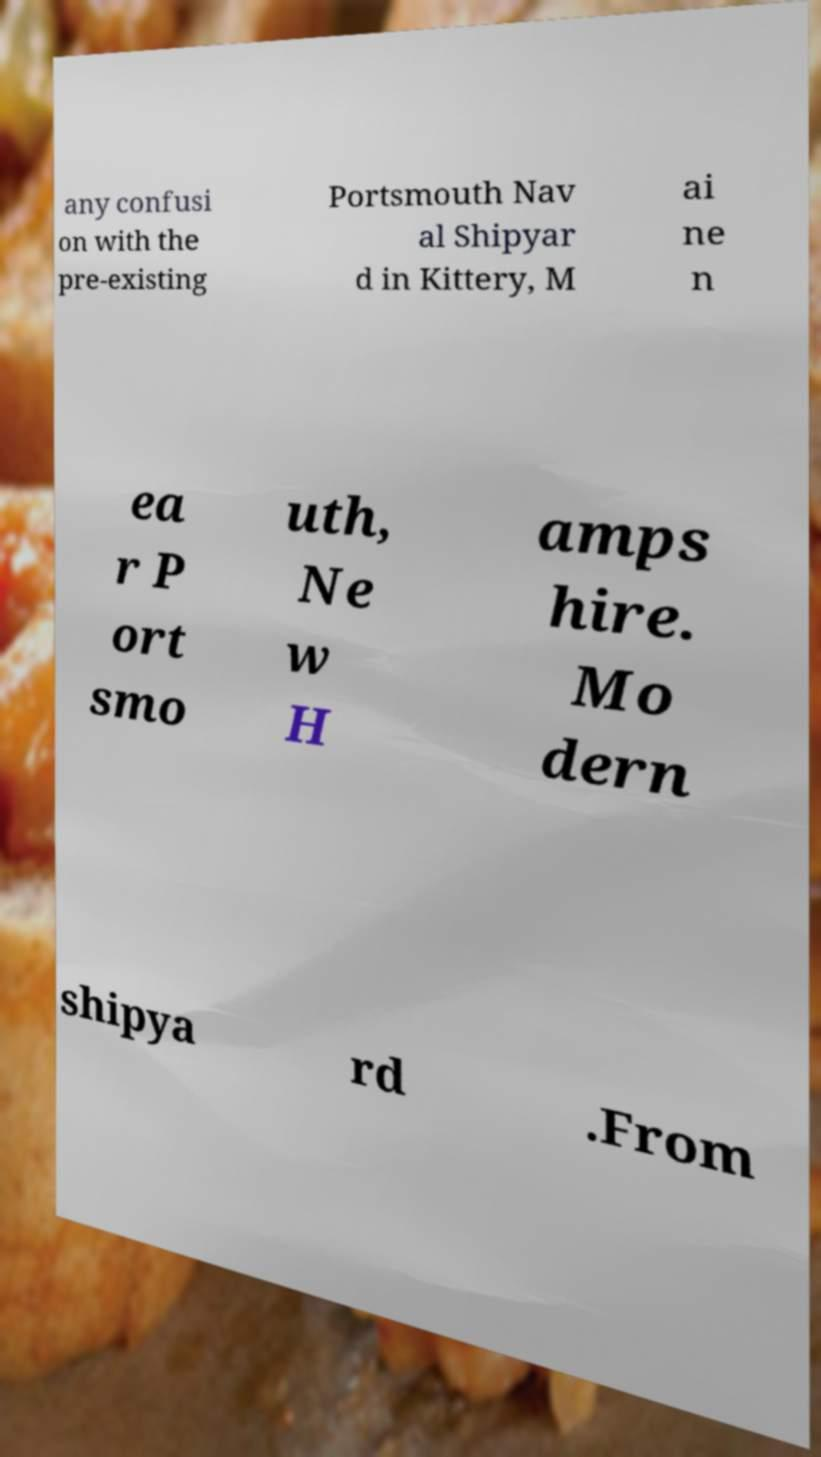Can you accurately transcribe the text from the provided image for me? any confusi on with the pre-existing Portsmouth Nav al Shipyar d in Kittery, M ai ne n ea r P ort smo uth, Ne w H amps hire. Mo dern shipya rd .From 